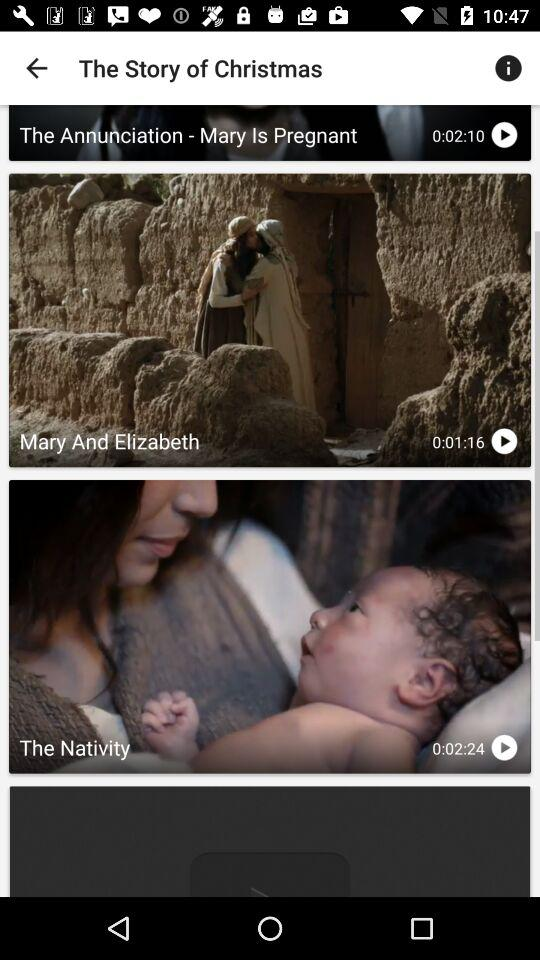Which language was selected? The selected language was English. 